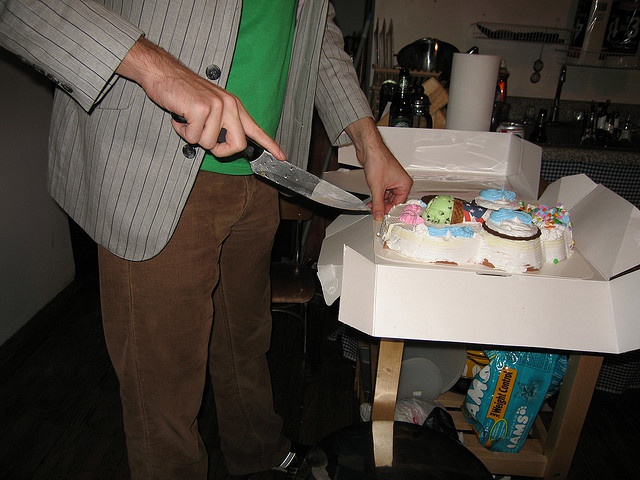Describe the objects in this image and their specific colors. I can see people in black, gray, and maroon tones, chair in black, maroon, and gray tones, cake in black, lightgray, beige, darkgray, and lightpink tones, cake in black, lightgray, darkgray, and beige tones, and knife in black, gray, and darkgray tones in this image. 